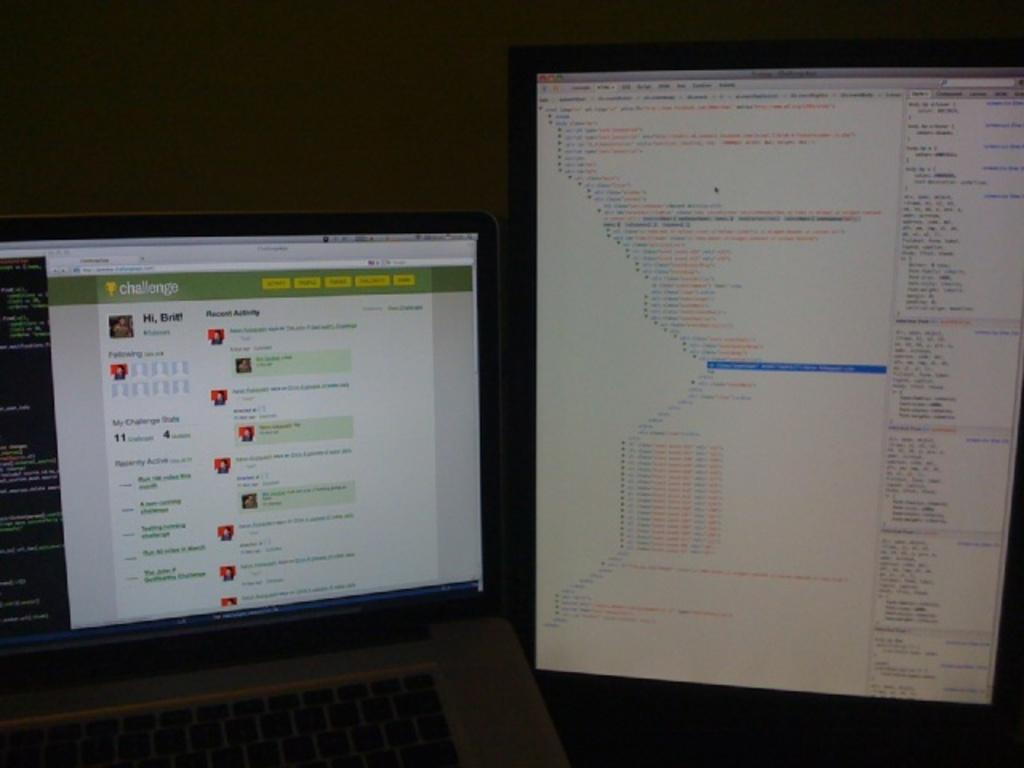<image>
Summarize the visual content of the image. A laptop is displaying a coding challenge website 